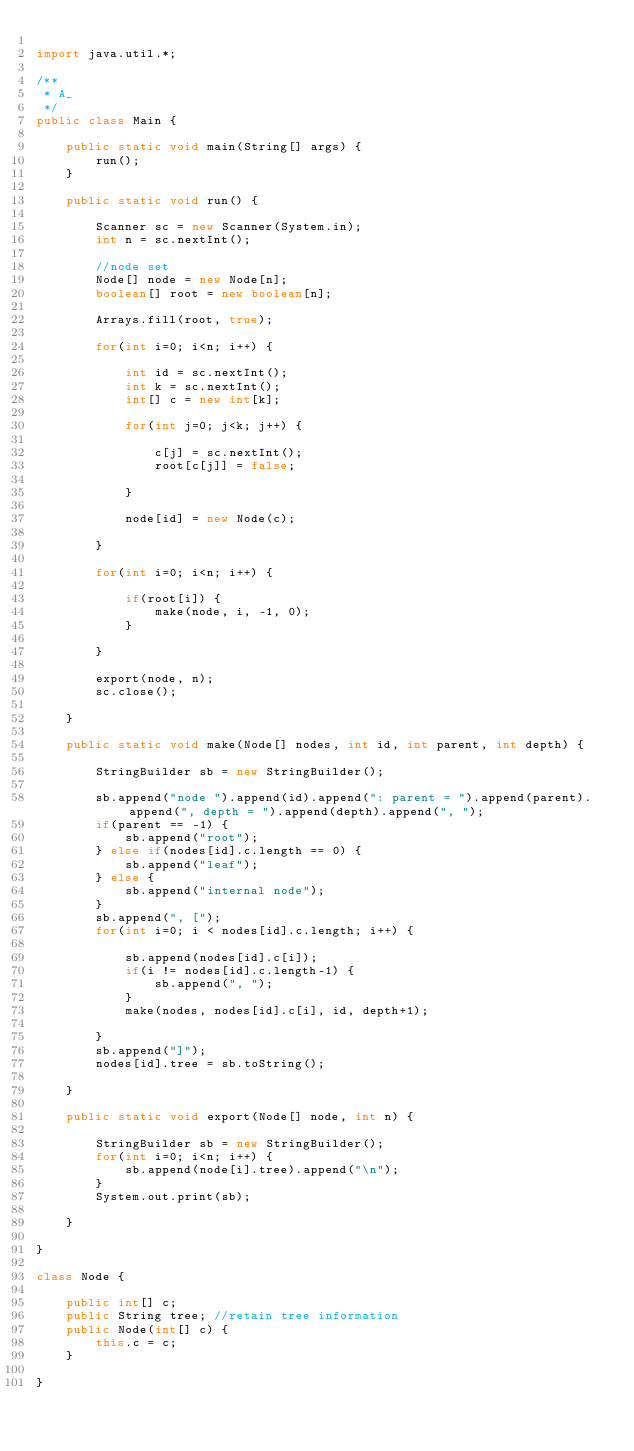Convert code to text. <code><loc_0><loc_0><loc_500><loc_500><_Java_>
import java.util.*;

/**
 * A_
 */
public class Main {

    public static void main(String[] args) {
        run();
    }

    public static void run() {
        
        Scanner sc = new Scanner(System.in);
        int n = sc.nextInt();

        //node set
        Node[] node = new Node[n];
        boolean[] root = new boolean[n];

        Arrays.fill(root, true);

        for(int i=0; i<n; i++) {

            int id = sc.nextInt();
            int k = sc.nextInt();
            int[] c = new int[k];

            for(int j=0; j<k; j++) {

                c[j] = sc.nextInt();
                root[c[j]] = false;

            }

            node[id] = new Node(c);

        }

        for(int i=0; i<n; i++) {

            if(root[i]) {
                make(node, i, -1, 0);
            }

        }

        export(node, n);
        sc.close();

    }

    public static void make(Node[] nodes, int id, int parent, int depth) {

        StringBuilder sb = new StringBuilder();

        sb.append("node ").append(id).append(": parent = ").append(parent).append(", depth = ").append(depth).append(", ");
        if(parent == -1) {
            sb.append("root");
        } else if(nodes[id].c.length == 0) {
            sb.append("leaf");
        } else {
            sb.append("internal node");
        }
        sb.append(", [");
        for(int i=0; i < nodes[id].c.length; i++) {

            sb.append(nodes[id].c[i]);
            if(i != nodes[id].c.length-1) {
                sb.append(", ");
            }
            make(nodes, nodes[id].c[i], id, depth+1);

        }
        sb.append("]");
        nodes[id].tree = sb.toString();

    }

    public static void export(Node[] node, int n) {

        StringBuilder sb = new StringBuilder();
        for(int i=0; i<n; i++) {
            sb.append(node[i].tree).append("\n");
        }
        System.out.print(sb);

    }

}

class Node {

    public int[] c;
    public String tree; //retain tree information
    public Node(int[] c) {
        this.c = c;
    }

}
</code> 